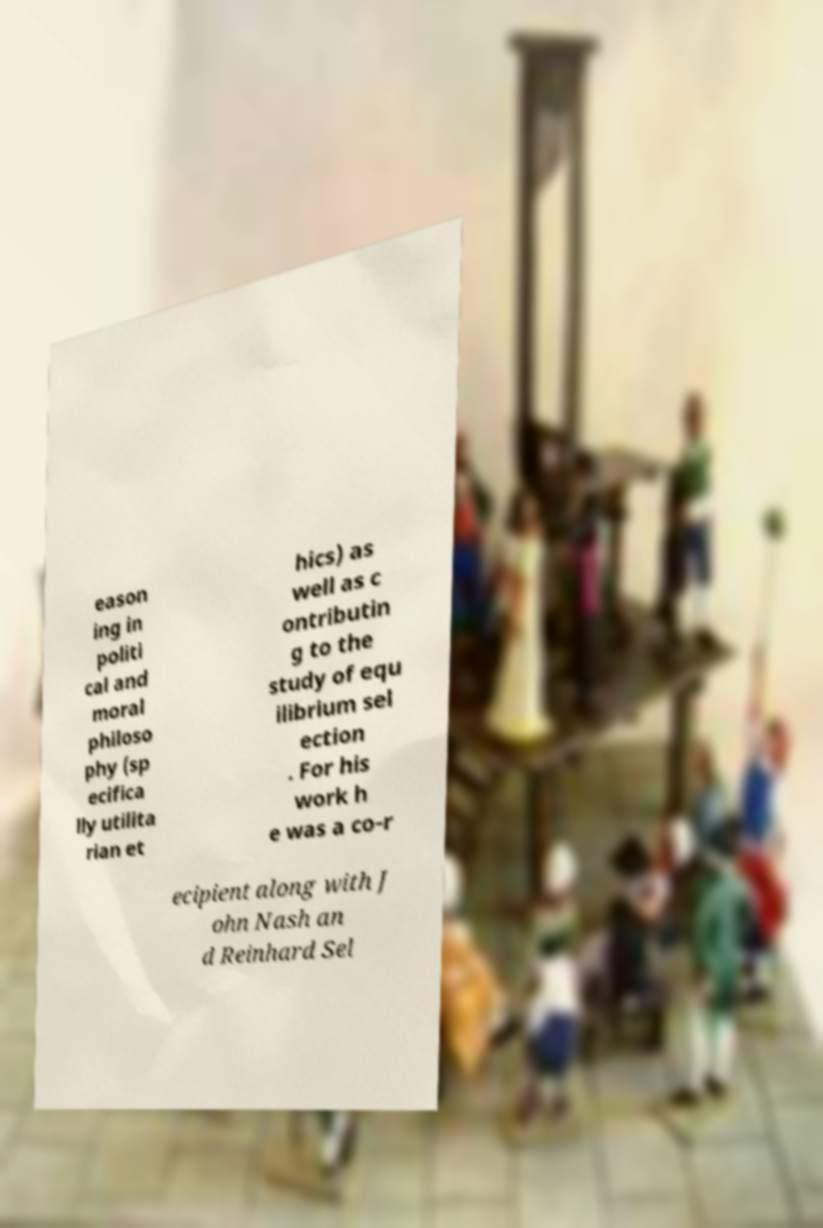I need the written content from this picture converted into text. Can you do that? eason ing in politi cal and moral philoso phy (sp ecifica lly utilita rian et hics) as well as c ontributin g to the study of equ ilibrium sel ection . For his work h e was a co-r ecipient along with J ohn Nash an d Reinhard Sel 